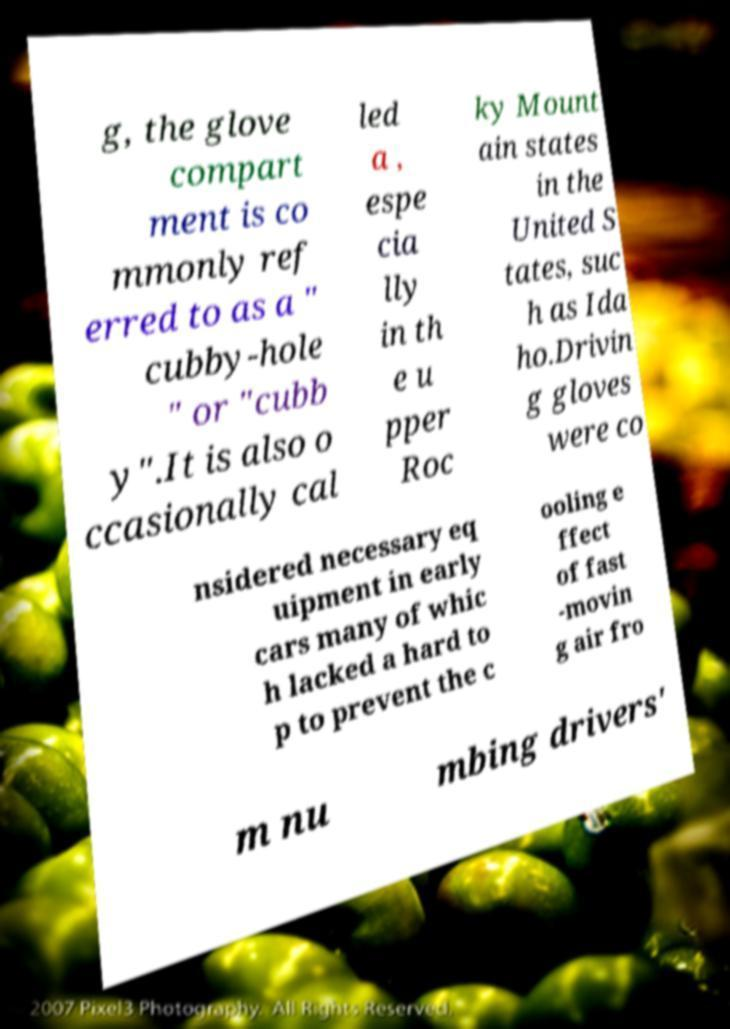Could you extract and type out the text from this image? g, the glove compart ment is co mmonly ref erred to as a " cubby-hole " or "cubb y".It is also o ccasionally cal led a , espe cia lly in th e u pper Roc ky Mount ain states in the United S tates, suc h as Ida ho.Drivin g gloves were co nsidered necessary eq uipment in early cars many of whic h lacked a hard to p to prevent the c ooling e ffect of fast -movin g air fro m nu mbing drivers' 